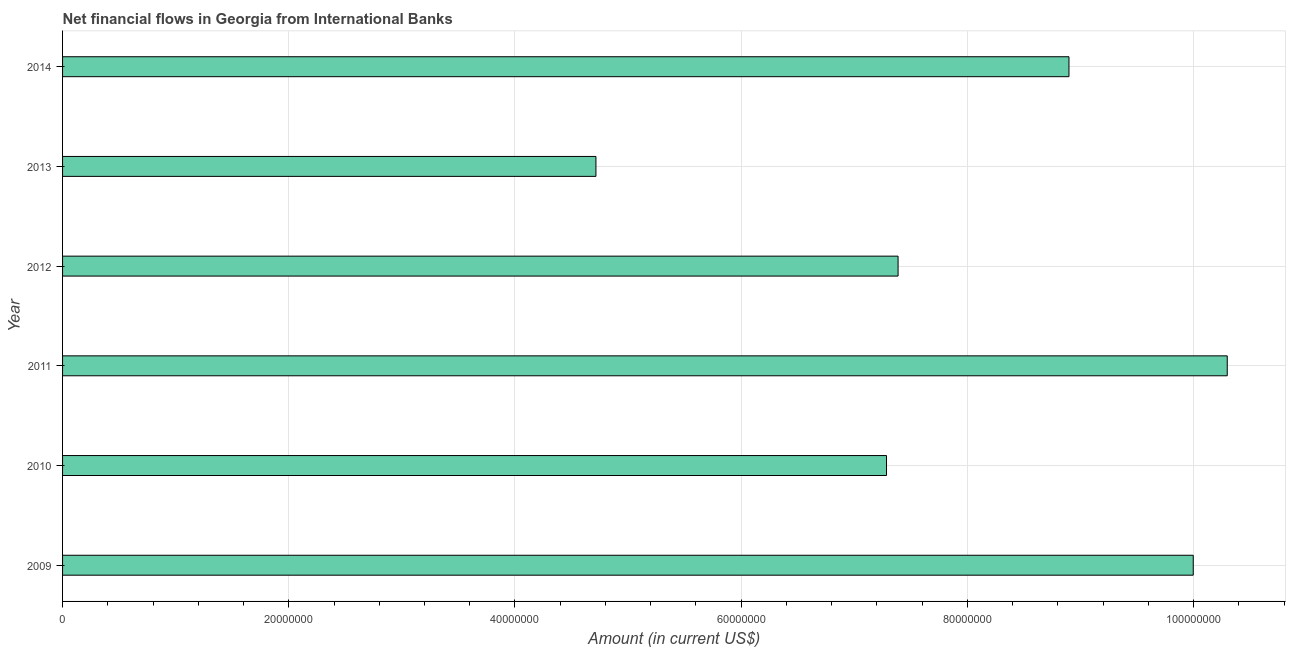What is the title of the graph?
Offer a terse response. Net financial flows in Georgia from International Banks. What is the net financial flows from ibrd in 2009?
Provide a succinct answer. 1.00e+08. Across all years, what is the maximum net financial flows from ibrd?
Offer a terse response. 1.03e+08. Across all years, what is the minimum net financial flows from ibrd?
Your answer should be compact. 4.72e+07. In which year was the net financial flows from ibrd minimum?
Keep it short and to the point. 2013. What is the sum of the net financial flows from ibrd?
Keep it short and to the point. 4.86e+08. What is the difference between the net financial flows from ibrd in 2011 and 2014?
Your response must be concise. 1.40e+07. What is the average net financial flows from ibrd per year?
Make the answer very short. 8.10e+07. What is the median net financial flows from ibrd?
Provide a short and direct response. 8.14e+07. In how many years, is the net financial flows from ibrd greater than 84000000 US$?
Give a very brief answer. 3. What is the ratio of the net financial flows from ibrd in 2010 to that in 2011?
Provide a succinct answer. 0.71. What is the difference between the highest and the second highest net financial flows from ibrd?
Keep it short and to the point. 3.01e+06. Is the sum of the net financial flows from ibrd in 2010 and 2012 greater than the maximum net financial flows from ibrd across all years?
Make the answer very short. Yes. What is the difference between the highest and the lowest net financial flows from ibrd?
Your response must be concise. 5.58e+07. In how many years, is the net financial flows from ibrd greater than the average net financial flows from ibrd taken over all years?
Provide a succinct answer. 3. How many bars are there?
Provide a succinct answer. 6. What is the Amount (in current US$) of 2009?
Make the answer very short. 1.00e+08. What is the Amount (in current US$) in 2010?
Keep it short and to the point. 7.28e+07. What is the Amount (in current US$) in 2011?
Give a very brief answer. 1.03e+08. What is the Amount (in current US$) of 2012?
Your answer should be very brief. 7.39e+07. What is the Amount (in current US$) in 2013?
Your answer should be very brief. 4.72e+07. What is the Amount (in current US$) in 2014?
Provide a short and direct response. 8.90e+07. What is the difference between the Amount (in current US$) in 2009 and 2010?
Your answer should be very brief. 2.71e+07. What is the difference between the Amount (in current US$) in 2009 and 2011?
Your answer should be compact. -3.01e+06. What is the difference between the Amount (in current US$) in 2009 and 2012?
Your response must be concise. 2.61e+07. What is the difference between the Amount (in current US$) in 2009 and 2013?
Your answer should be compact. 5.28e+07. What is the difference between the Amount (in current US$) in 2009 and 2014?
Make the answer very short. 1.10e+07. What is the difference between the Amount (in current US$) in 2010 and 2011?
Offer a very short reply. -3.01e+07. What is the difference between the Amount (in current US$) in 2010 and 2012?
Give a very brief answer. -1.02e+06. What is the difference between the Amount (in current US$) in 2010 and 2013?
Keep it short and to the point. 2.57e+07. What is the difference between the Amount (in current US$) in 2010 and 2014?
Keep it short and to the point. -1.61e+07. What is the difference between the Amount (in current US$) in 2011 and 2012?
Ensure brevity in your answer.  2.91e+07. What is the difference between the Amount (in current US$) in 2011 and 2013?
Provide a succinct answer. 5.58e+07. What is the difference between the Amount (in current US$) in 2011 and 2014?
Ensure brevity in your answer.  1.40e+07. What is the difference between the Amount (in current US$) in 2012 and 2013?
Offer a very short reply. 2.67e+07. What is the difference between the Amount (in current US$) in 2012 and 2014?
Ensure brevity in your answer.  -1.51e+07. What is the difference between the Amount (in current US$) in 2013 and 2014?
Your answer should be compact. -4.18e+07. What is the ratio of the Amount (in current US$) in 2009 to that in 2010?
Provide a short and direct response. 1.37. What is the ratio of the Amount (in current US$) in 2009 to that in 2012?
Offer a terse response. 1.35. What is the ratio of the Amount (in current US$) in 2009 to that in 2013?
Your answer should be very brief. 2.12. What is the ratio of the Amount (in current US$) in 2009 to that in 2014?
Provide a short and direct response. 1.12. What is the ratio of the Amount (in current US$) in 2010 to that in 2011?
Offer a very short reply. 0.71. What is the ratio of the Amount (in current US$) in 2010 to that in 2012?
Your response must be concise. 0.99. What is the ratio of the Amount (in current US$) in 2010 to that in 2013?
Your answer should be very brief. 1.54. What is the ratio of the Amount (in current US$) in 2010 to that in 2014?
Give a very brief answer. 0.82. What is the ratio of the Amount (in current US$) in 2011 to that in 2012?
Provide a succinct answer. 1.39. What is the ratio of the Amount (in current US$) in 2011 to that in 2013?
Provide a succinct answer. 2.18. What is the ratio of the Amount (in current US$) in 2011 to that in 2014?
Keep it short and to the point. 1.16. What is the ratio of the Amount (in current US$) in 2012 to that in 2013?
Provide a short and direct response. 1.57. What is the ratio of the Amount (in current US$) in 2012 to that in 2014?
Provide a short and direct response. 0.83. What is the ratio of the Amount (in current US$) in 2013 to that in 2014?
Keep it short and to the point. 0.53. 